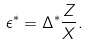Convert formula to latex. <formula><loc_0><loc_0><loc_500><loc_500>\epsilon ^ { * } = \Delta ^ { * } \frac { Z } { X } .</formula> 